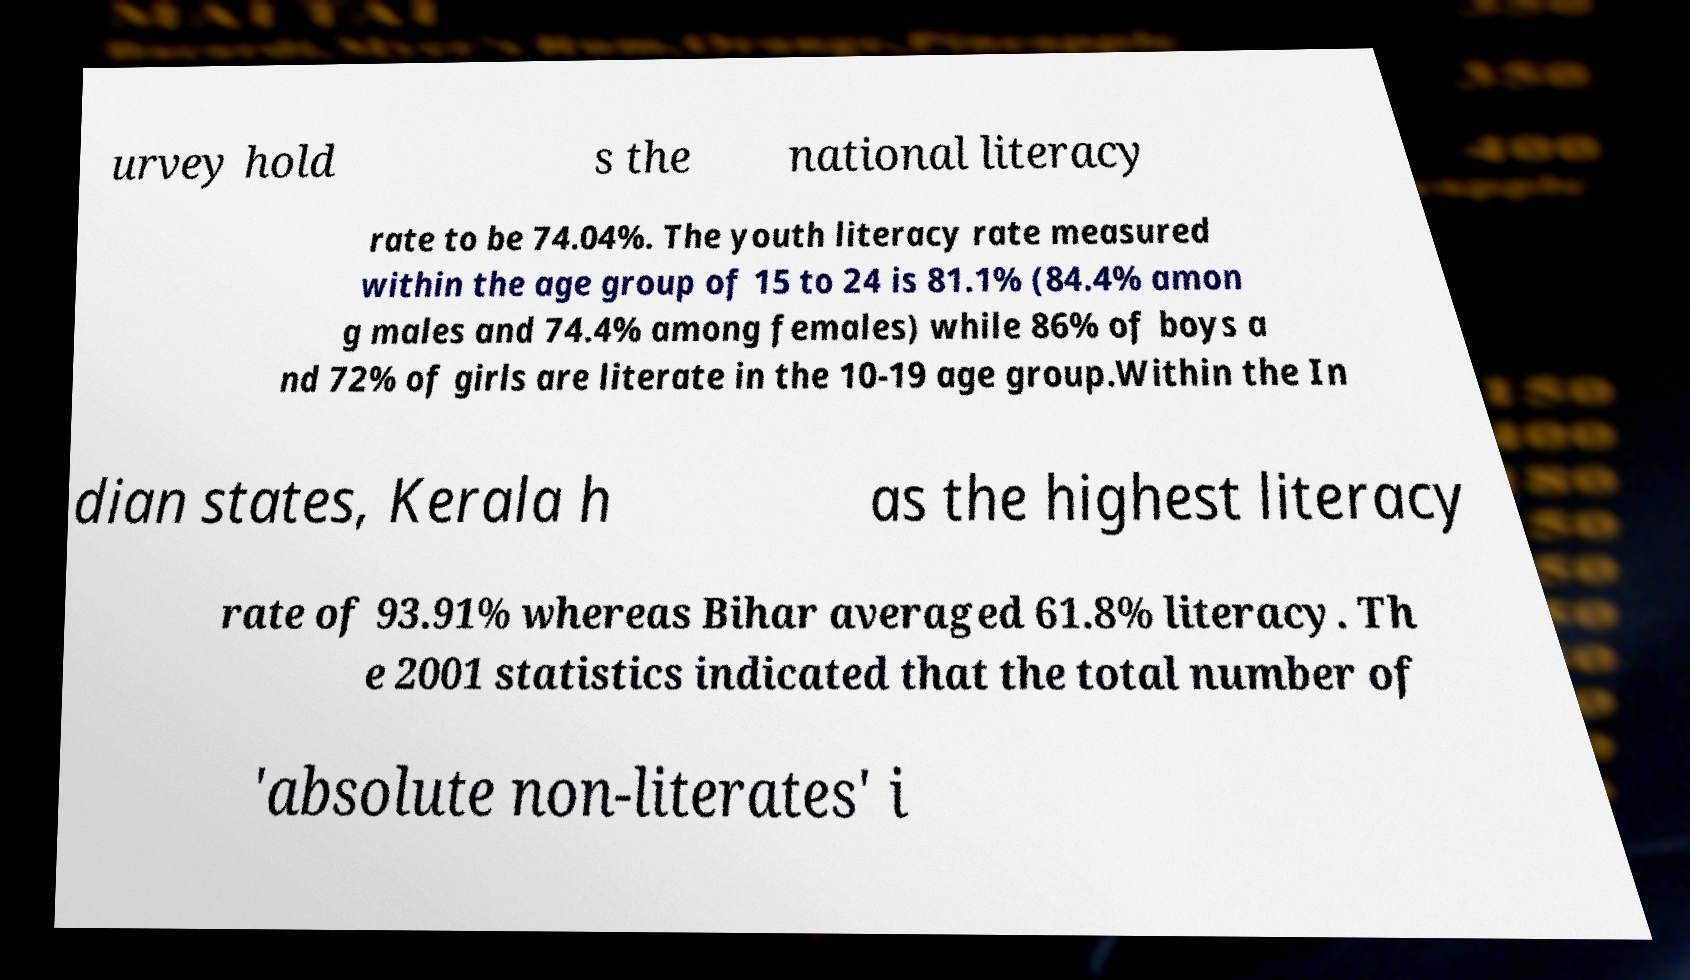Can you accurately transcribe the text from the provided image for me? urvey hold s the national literacy rate to be 74.04%. The youth literacy rate measured within the age group of 15 to 24 is 81.1% (84.4% amon g males and 74.4% among females) while 86% of boys a nd 72% of girls are literate in the 10-19 age group.Within the In dian states, Kerala h as the highest literacy rate of 93.91% whereas Bihar averaged 61.8% literacy. Th e 2001 statistics indicated that the total number of 'absolute non-literates' i 